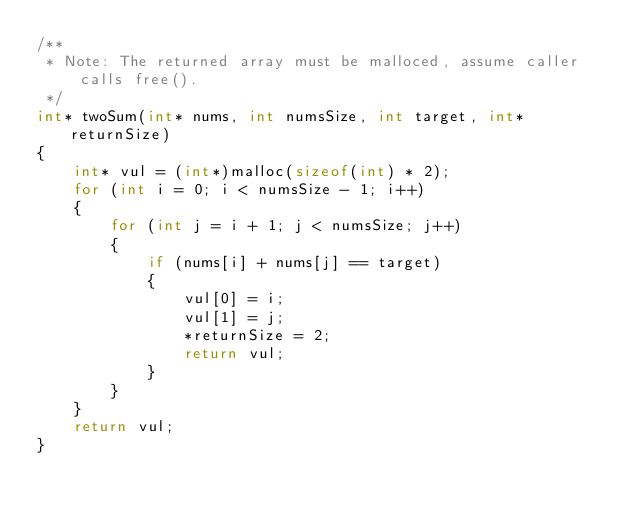<code> <loc_0><loc_0><loc_500><loc_500><_C_>/**
 * Note: The returned array must be malloced, assume caller calls free().
 */
int* twoSum(int* nums, int numsSize, int target, int* returnSize)
{
    int* vul = (int*)malloc(sizeof(int) * 2);
    for (int i = 0; i < numsSize - 1; i++)
    {
        for (int j = i + 1; j < numsSize; j++)
        {
            if (nums[i] + nums[j] == target)
            {
                vul[0] = i;
                vul[1] = j;
                *returnSize = 2;
                return vul;
            }
        }
    }
    return vul;
}</code> 